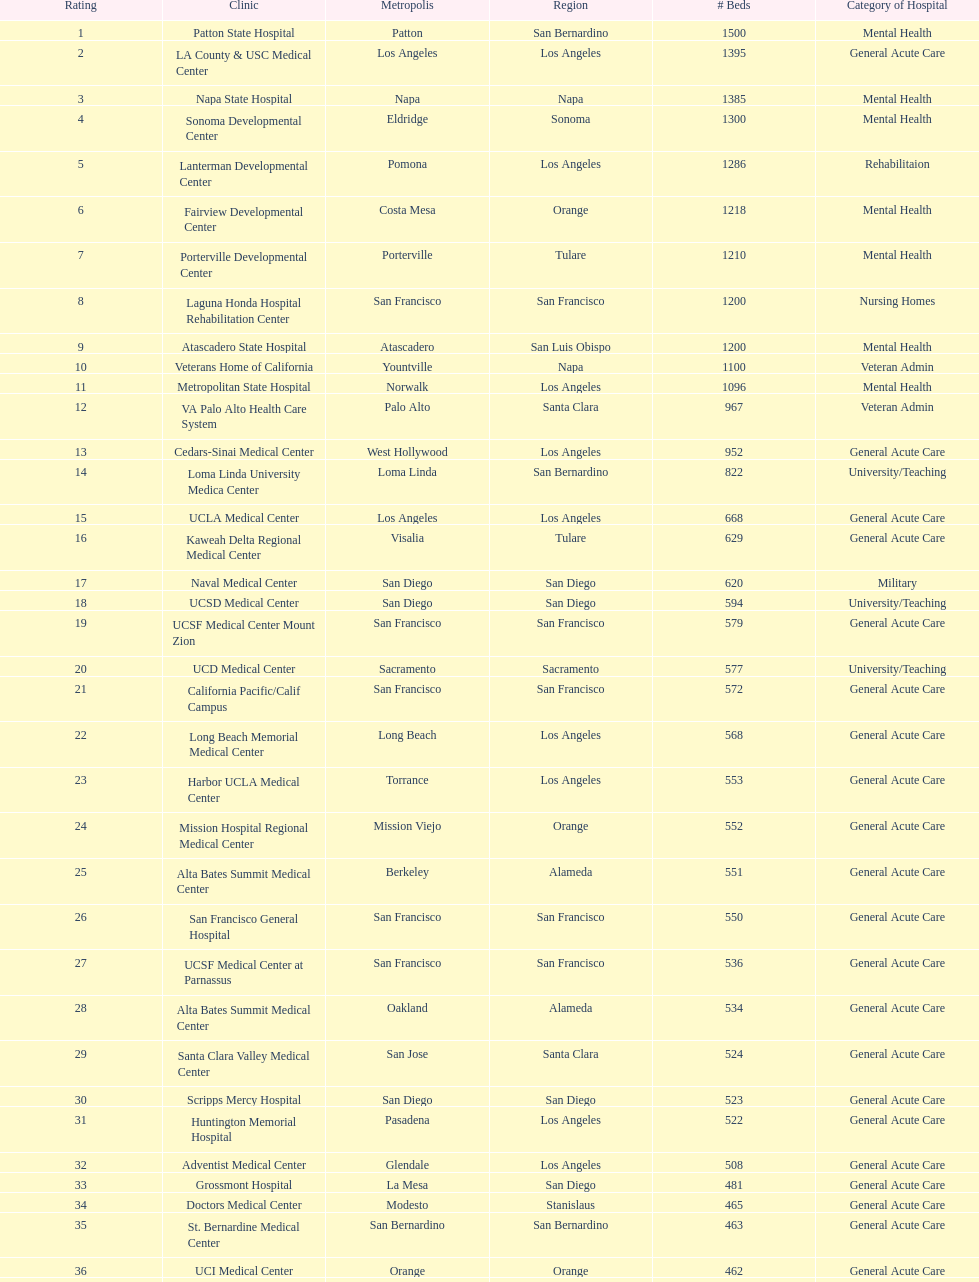How much larger (in number of beds) was the largest hospital in california than the 50th largest? 1071. 